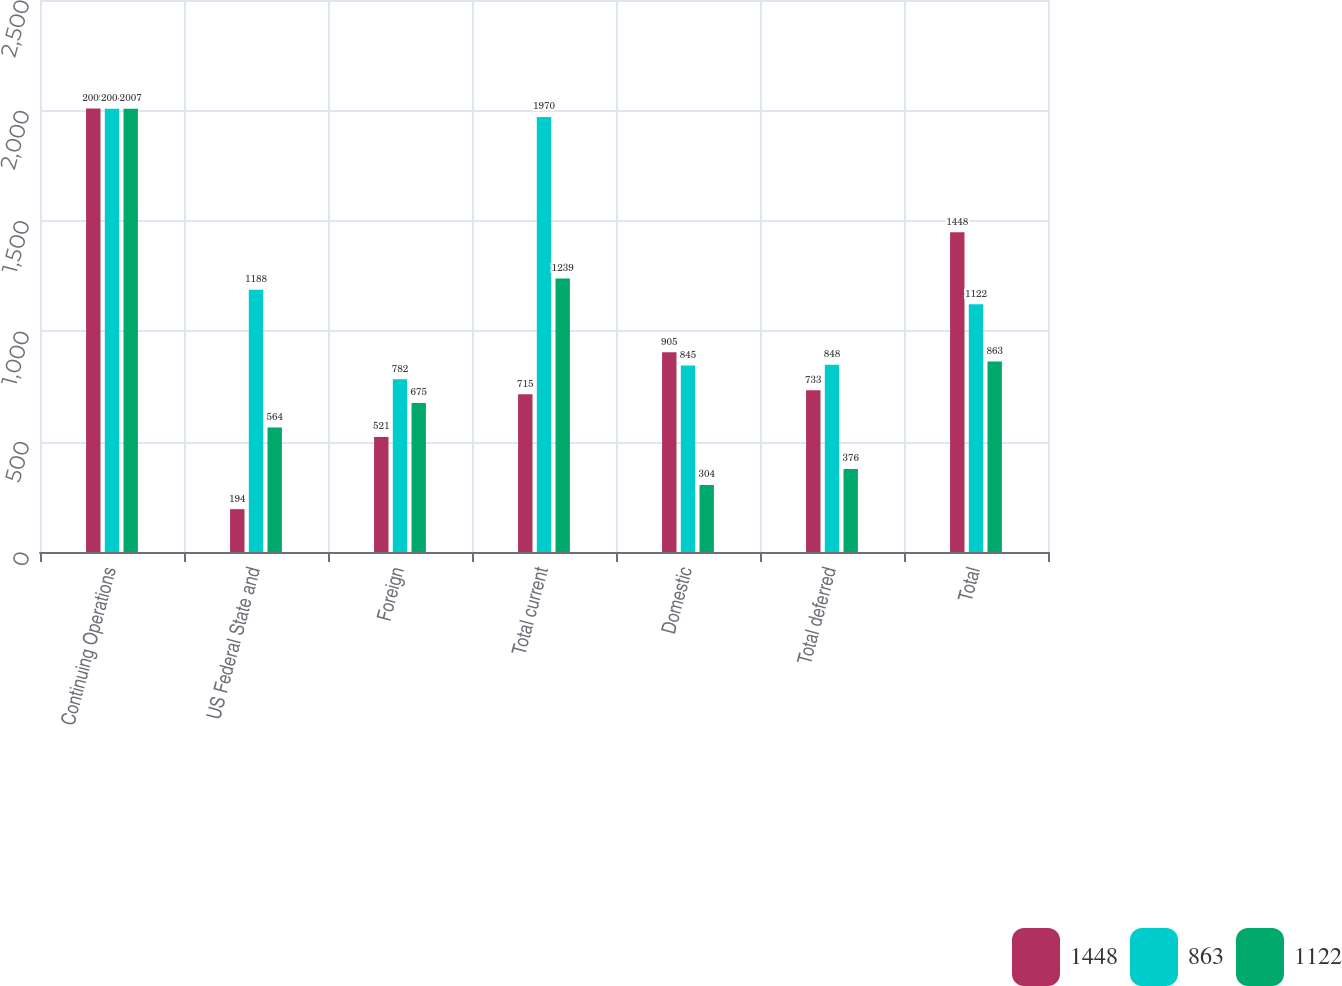<chart> <loc_0><loc_0><loc_500><loc_500><stacked_bar_chart><ecel><fcel>Continuing Operations<fcel>US Federal State and<fcel>Foreign<fcel>Total current<fcel>Domestic<fcel>Total deferred<fcel>Total<nl><fcel>1448<fcel>2009<fcel>194<fcel>521<fcel>715<fcel>905<fcel>733<fcel>1448<nl><fcel>863<fcel>2008<fcel>1188<fcel>782<fcel>1970<fcel>845<fcel>848<fcel>1122<nl><fcel>1122<fcel>2007<fcel>564<fcel>675<fcel>1239<fcel>304<fcel>376<fcel>863<nl></chart> 